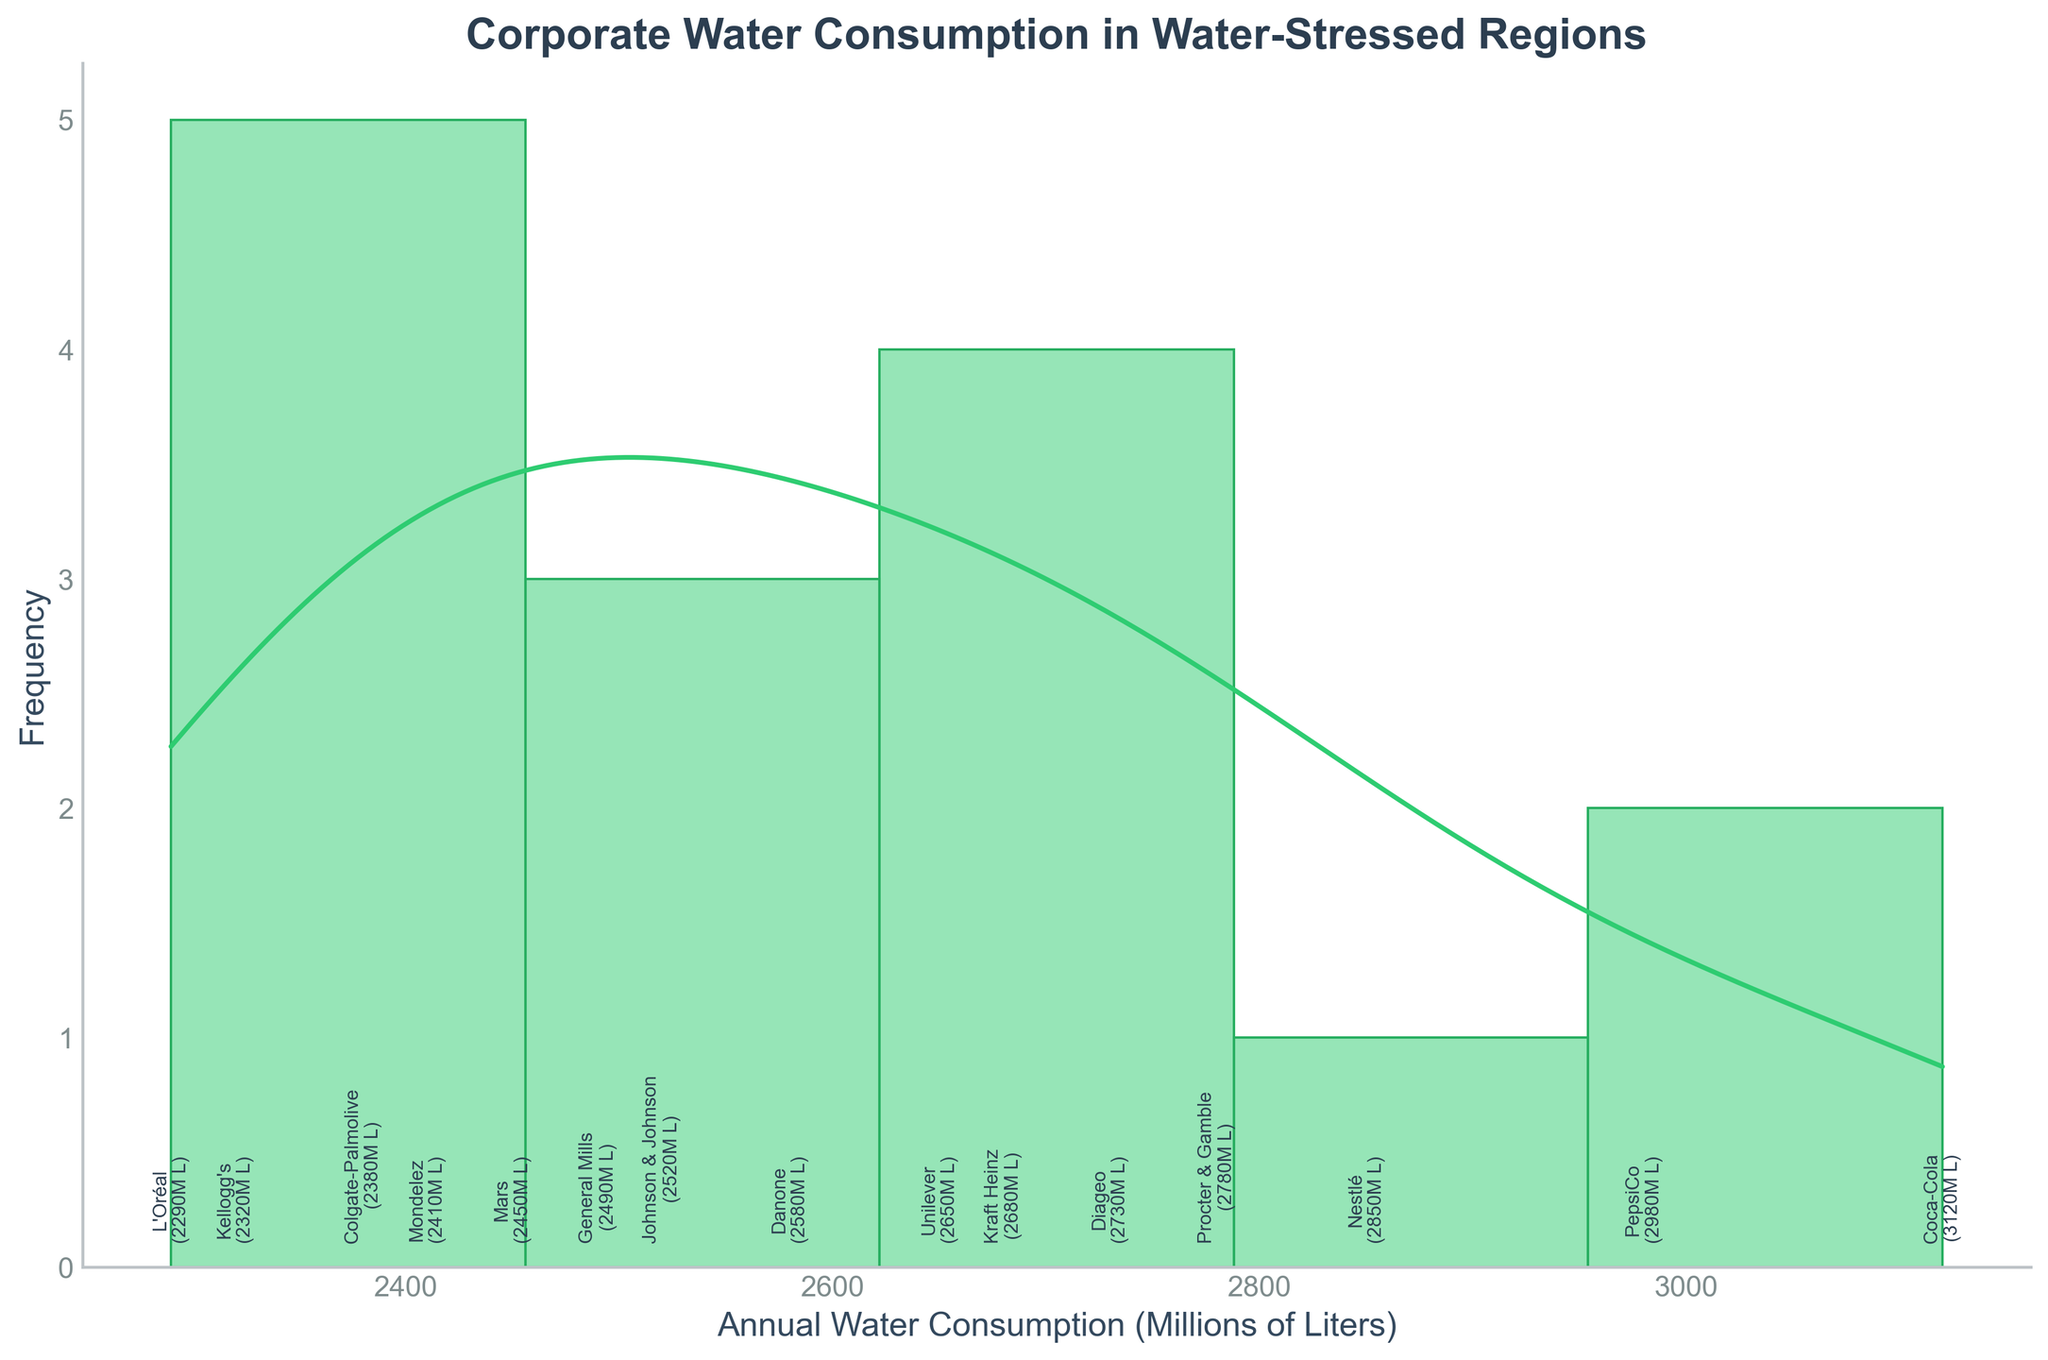What's the title of the figure? The title is placed at the top of the figure and is styled with bold lettering to stand out. The figure title indicates the subject of the plot.
Answer: Corporate Water Consumption in Water-Stressed Regions How many corporations are depicted in the figure? The histogram shows several distinct bars, each associated with a corporation's water consumption rate. Each bar's label can be used to count the number of corporations represented.
Answer: 15 What's the range of the annual water consumption values for the corporations? The x-axis of the histogram displays the annual water consumption in millions of liters. The lowest and highest values on this axis give the range.
Answer: 2290 to 3120 million liters Which corporation has the highest annual water consumption? Each corporation's consumption value is annotated next to its corresponding bar in the histogram. The bar with the highest value represents the corporation with the highest consumption.
Answer: Coca-Cola What's the total annual water consumption of all the corporations combined? To find the total, sum the annual water consumption values of each corporation displayed on the histogram.
Answer: 41250 million liters What's the average annual water consumption of the corporations? Since the total annual water consumption is 41250 million liters and there are 15 corporations, the average can be calculated by dividing the total by the number of corporations.
Answer: 2750 million liters What does the KDE curve indicate in this plot? The KDE (kernel density estimate) curve overlays the histogram to show the probability density function of the data. It provides a smoothed estimate of the data distribution, indicating the density of corporations' water consumption values.
Answer: Density distribution of water consumption How does Mondelez's water consumption compare to that of Unilever? Locate the bars/annotations for Mondelez and Unilever. Compare the water consumption values indicated for each.
Answer: Mondelez has a lower consumption than Unilever Which corporation is closest to the average annual water consumption? The average consumption is around 2750 million liters. Locate the corporation whose consumption value is closest to this average on the histogram.
Answer: Procter & Gamble What's the purpose of adding annotation labels to the bars in the histogram? Annotations next to each bar provide specific data points and make it easier to identify the corporation and its exact water consumption without referring back to a data table.
Answer: To identify corporations and their exact water consumption 